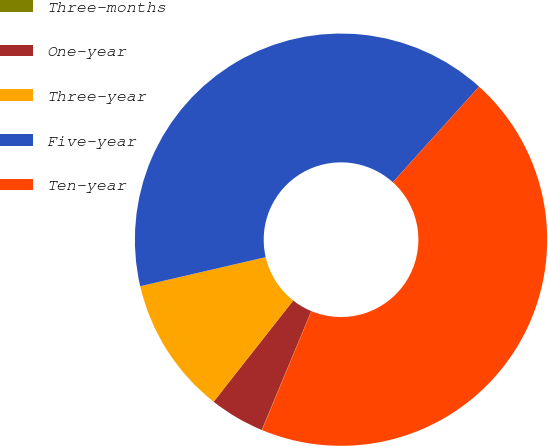<chart> <loc_0><loc_0><loc_500><loc_500><pie_chart><fcel>Three-months<fcel>One-year<fcel>Three-year<fcel>Five-year<fcel>Ten-year<nl><fcel>0.03%<fcel>4.32%<fcel>10.77%<fcel>40.3%<fcel>44.58%<nl></chart> 